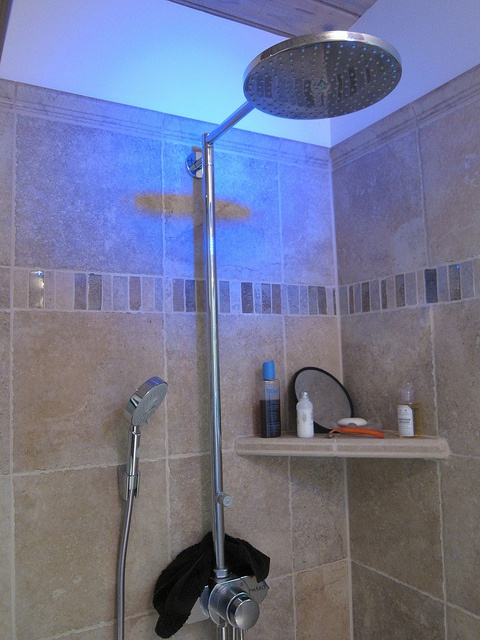Describe the objects in this image and their specific colors. I can see bottle in gray and darkgray tones and bottle in gray, black, and navy tones in this image. 